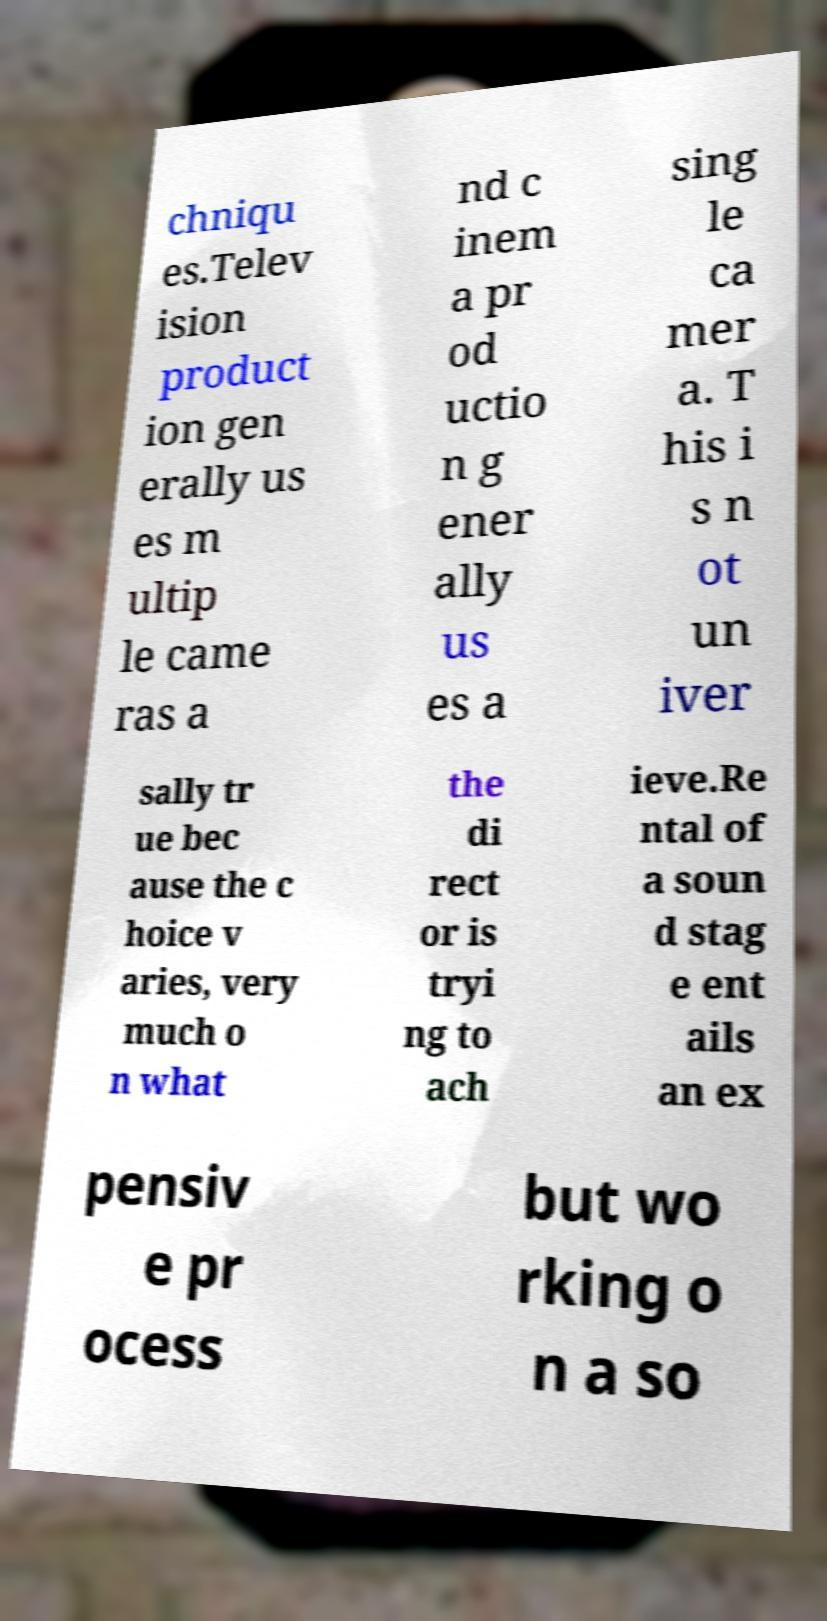Could you extract and type out the text from this image? chniqu es.Telev ision product ion gen erally us es m ultip le came ras a nd c inem a pr od uctio n g ener ally us es a sing le ca mer a. T his i s n ot un iver sally tr ue bec ause the c hoice v aries, very much o n what the di rect or is tryi ng to ach ieve.Re ntal of a soun d stag e ent ails an ex pensiv e pr ocess but wo rking o n a so 